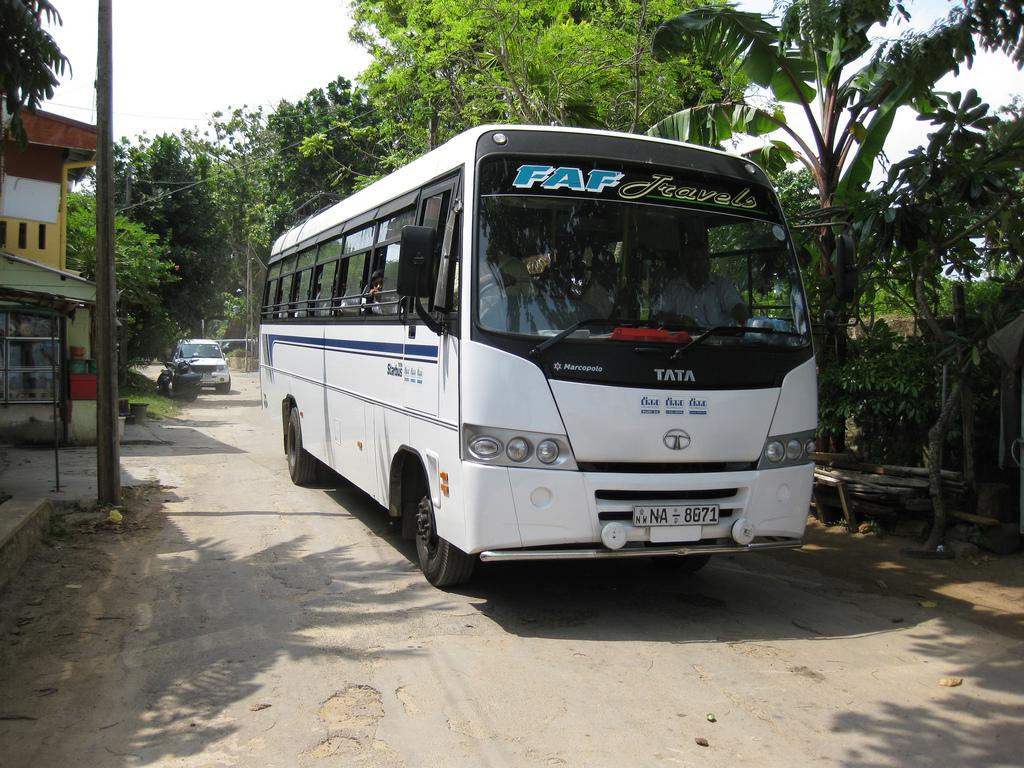Question: what is in the picture?
Choices:
A. A passenger.
B. A bus.
C. A car.
D. A highway.
Answer with the letter. Answer: B Question: when was this picture taken?
Choices:
A. Early evening.
B. Noon.
C. Nighttime.
D. Day time.
Answer with the letter. Answer: D Question: what does the top of the bus say?
Choices:
A. Greyhound.
B. FAF travels.
C. Amtrak.
D. School.
Answer with the letter. Answer: B Question: who is driving the bus?
Choices:
A. A bus driver.
B. A man.
C. A woman.
D. A passenger.
Answer with the letter. Answer: A Question: where was this picture taken?
Choices:
A. In a school.
B. On a porch.
C. In a cave.
D. On the street.
Answer with the letter. Answer: D Question: where was the photo taken?
Choices:
A. On a road in a tropical place.
B. In the Keys.
C. In Hawaii.
D. In Traverse City, Michigan.
Answer with the letter. Answer: A Question: what does the bus sign say?
Choices:
A. Grey Hound.
B. Travel Ways.
C. Blue Bird.
D. Faf travels.
Answer with the letter. Answer: D Question: what letters are below the windshield?
Choices:
A. Bing.
B. Champ.
C. Tata.
D. Ratt.
Answer with the letter. Answer: C Question: what is driving down the road?
Choices:
A. A moped.
B. A bus.
C. A camper.
D. A semi truck.
Answer with the letter. Answer: B Question: what lines the road?
Choices:
A. Trees.
B. Sidewalk.
C. Flowerbeds.
D. Gravel.
Answer with the letter. Answer: A Question: what's on the side of the road?
Choices:
A. A curb.
B. Some trees.
C. A bush.
D. A stop sign.
Answer with the letter. Answer: B Question: what's in the road?
Choices:
A. A car.
B. A large white bus.
C. A truck.
D. A van.
Answer with the letter. Answer: B Question: what color stripe is on the bus?
Choices:
A. Blue.
B. Red.
C. Green.
D. Black.
Answer with the letter. Answer: A Question: what colors is the tata bus?
Choices:
A. Red and blue.
B. Red and white.
C. Black and white.
D. Blue and white.
Answer with the letter. Answer: C Question: how might you describe the road surface?
Choices:
A. Smooth.
B. Cracked.
C. Bumpy.
D. Dark.
Answer with the letter. Answer: B Question: what position are most of the bus windows in?
Choices:
A. Closed.
B. Open.
C. On the side.
D. In the front.
Answer with the letter. Answer: B Question: what is on the street?
Choices:
A. A bike rider.
B. A bus and a truck.
C. Glass.
D. A few animals.
Answer with the letter. Answer: B 